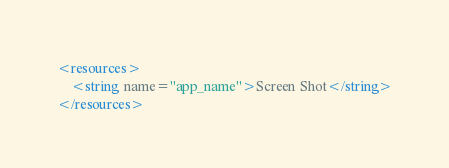<code> <loc_0><loc_0><loc_500><loc_500><_XML_><resources>
    <string name="app_name">Screen Shot</string>
</resources>
</code> 